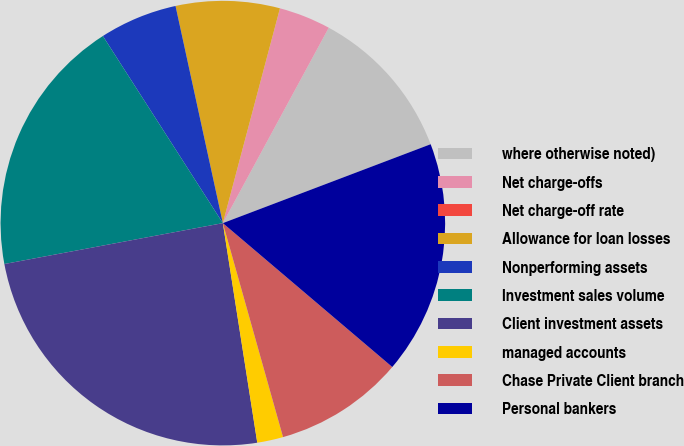Convert chart to OTSL. <chart><loc_0><loc_0><loc_500><loc_500><pie_chart><fcel>where otherwise noted)<fcel>Net charge-offs<fcel>Net charge-off rate<fcel>Allowance for loan losses<fcel>Nonperforming assets<fcel>Investment sales volume<fcel>Client investment assets<fcel>managed accounts<fcel>Chase Private Client branch<fcel>Personal bankers<nl><fcel>11.32%<fcel>3.77%<fcel>0.0%<fcel>7.55%<fcel>5.66%<fcel>18.87%<fcel>24.53%<fcel>1.89%<fcel>9.43%<fcel>16.98%<nl></chart> 